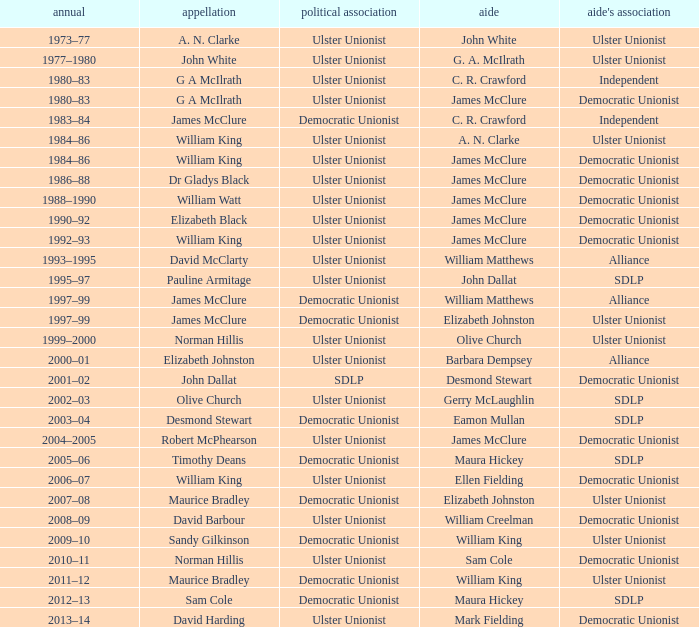What is the Deputy's affiliation in 1992–93? Democratic Unionist. 